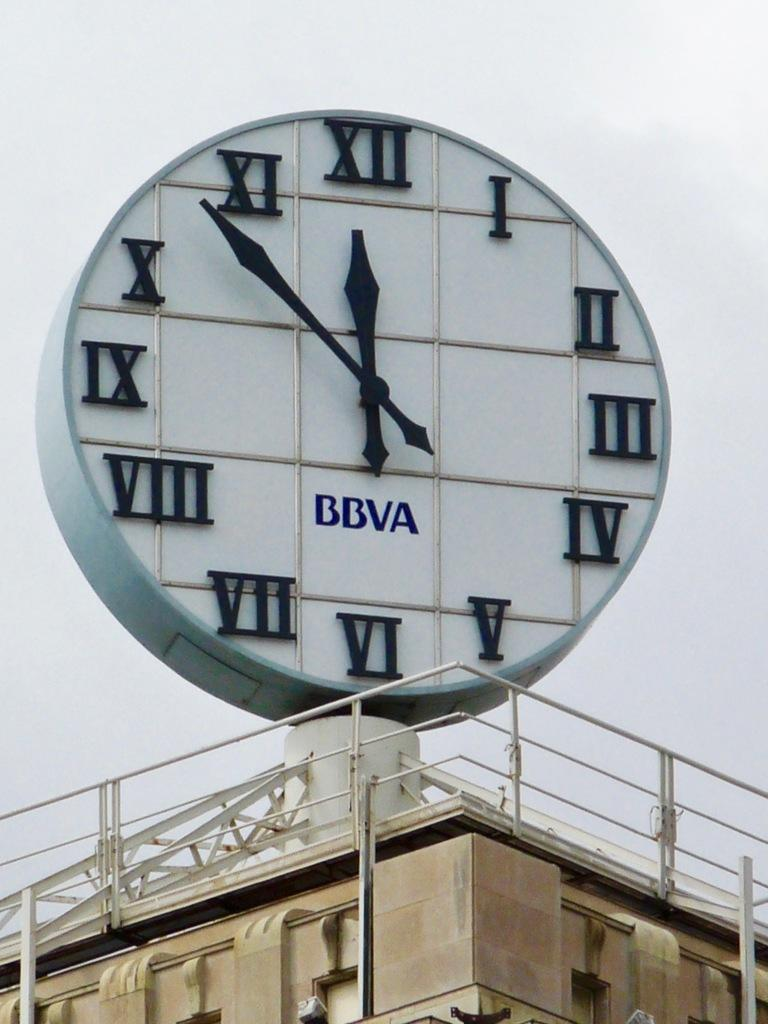<image>
Summarize the visual content of the image. A large clock with roman numerals with the bbva logo on the bottom of it. 